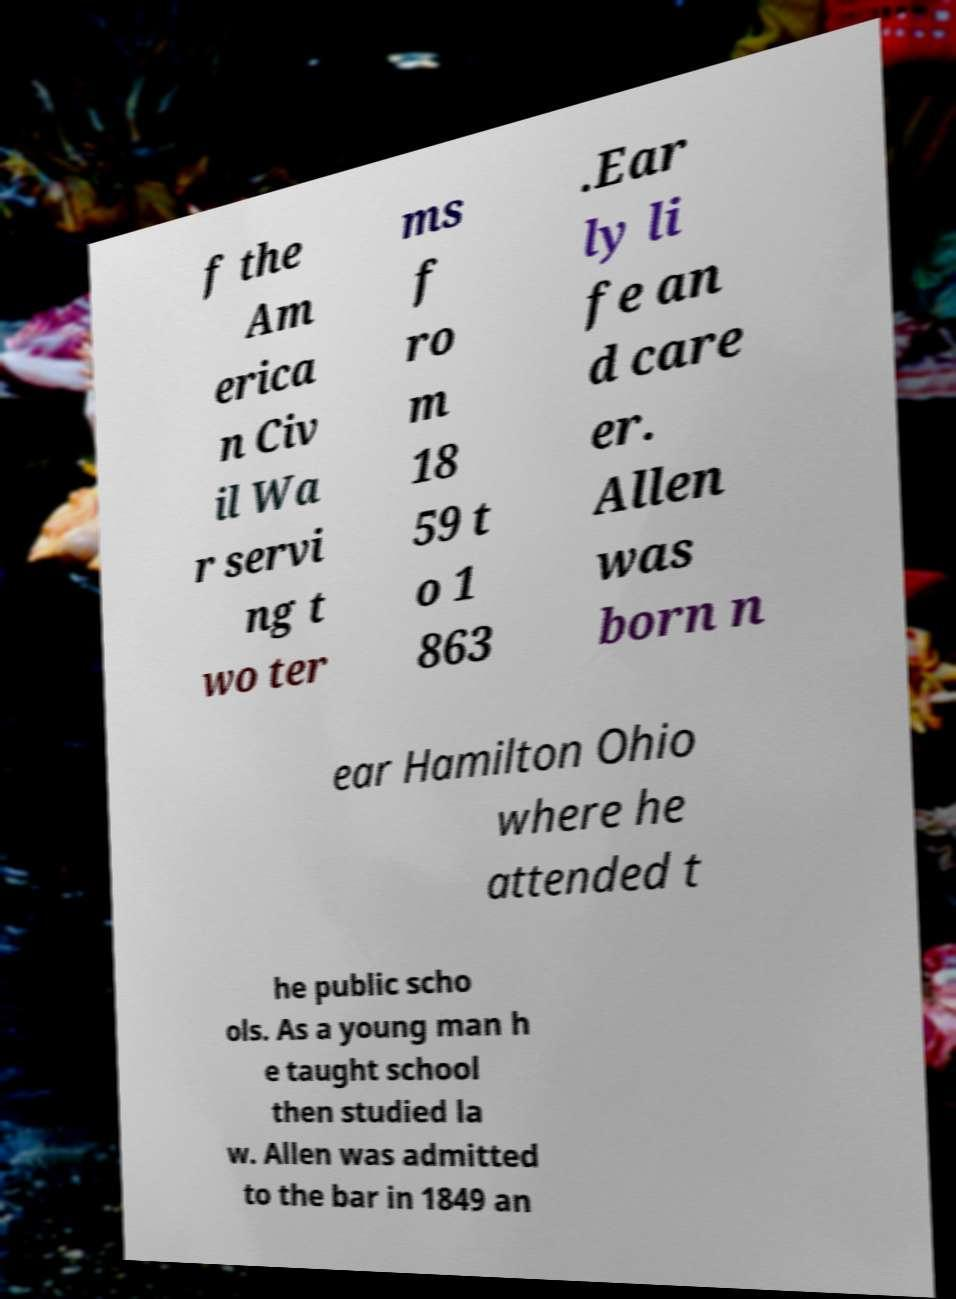For documentation purposes, I need the text within this image transcribed. Could you provide that? f the Am erica n Civ il Wa r servi ng t wo ter ms f ro m 18 59 t o 1 863 .Ear ly li fe an d care er. Allen was born n ear Hamilton Ohio where he attended t he public scho ols. As a young man h e taught school then studied la w. Allen was admitted to the bar in 1849 an 